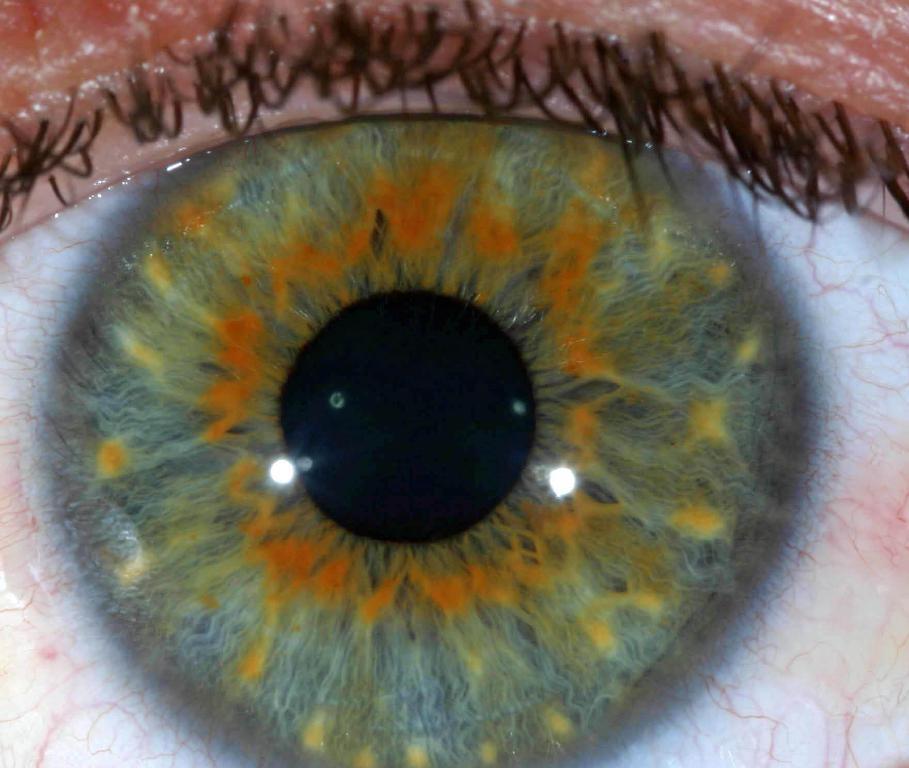Please provide a concise description of this image. In this picture, we see the eye and the eyeball of the person. It is in green, orange, white and black color. At the top, we see the eyelashes, which are black in color. 